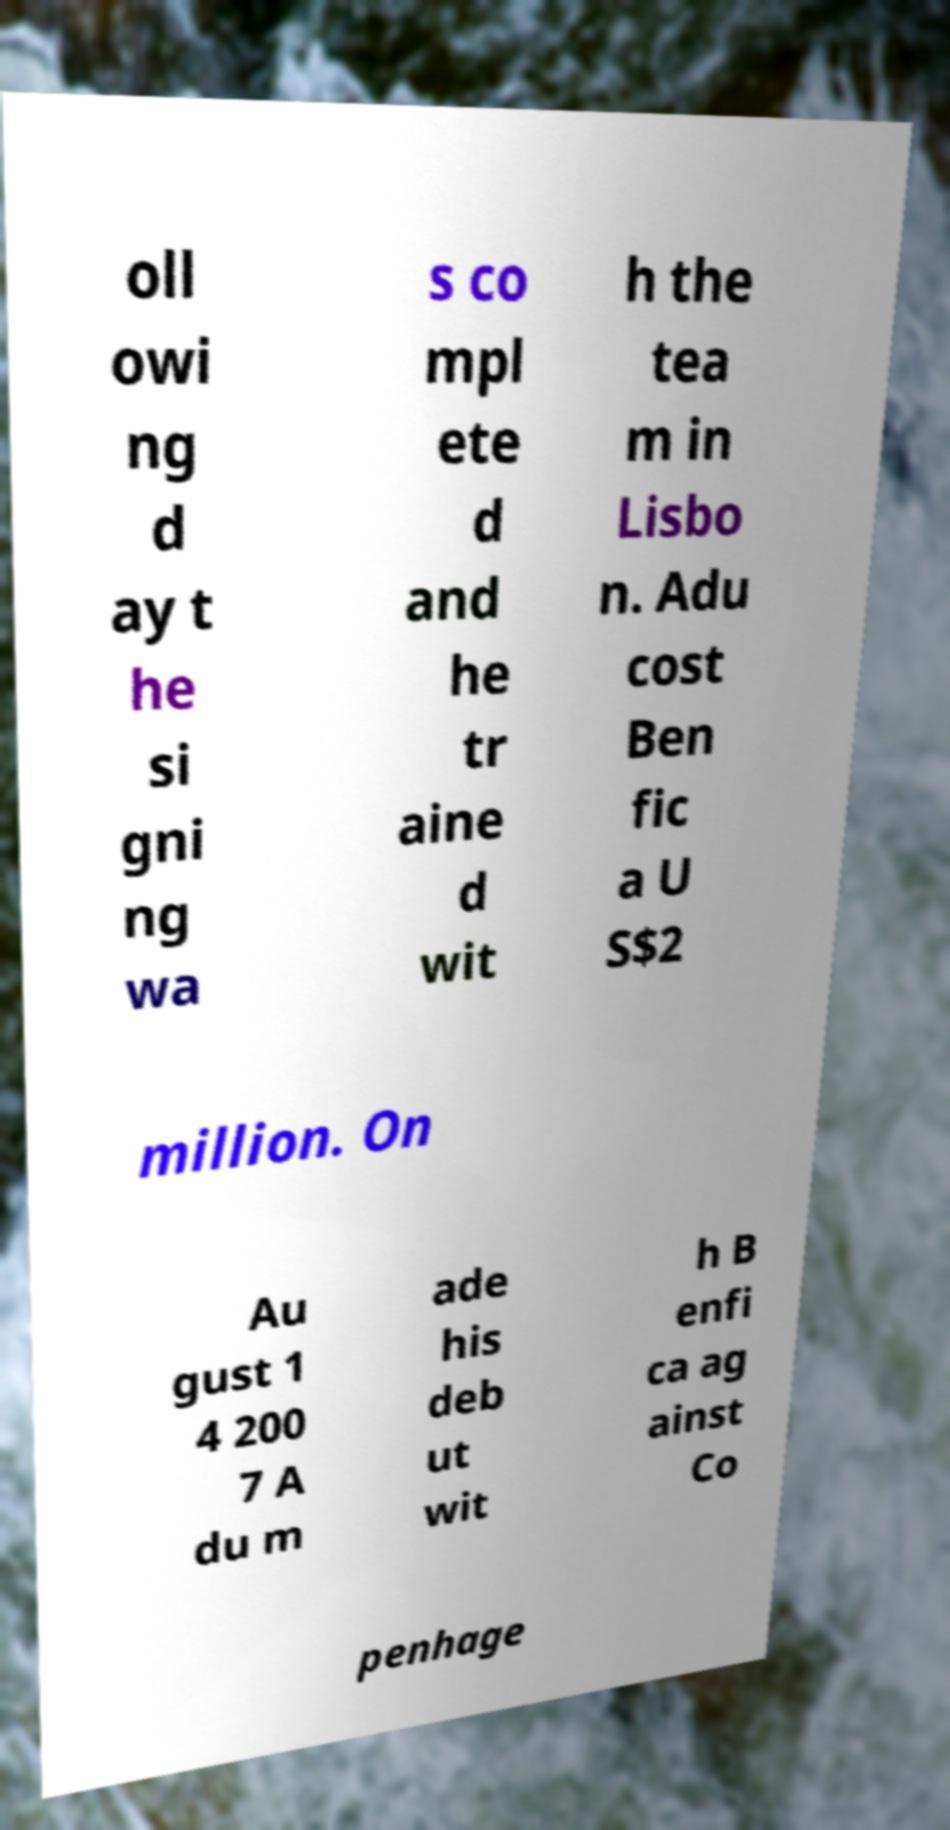For documentation purposes, I need the text within this image transcribed. Could you provide that? oll owi ng d ay t he si gni ng wa s co mpl ete d and he tr aine d wit h the tea m in Lisbo n. Adu cost Ben fic a U S$2 million. On Au gust 1 4 200 7 A du m ade his deb ut wit h B enfi ca ag ainst Co penhage 